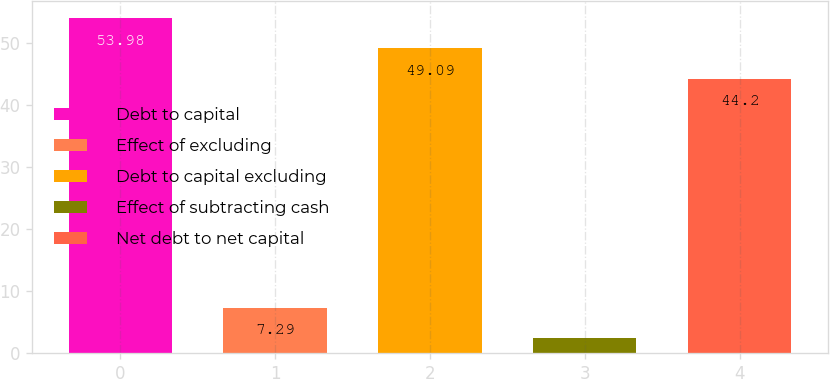Convert chart to OTSL. <chart><loc_0><loc_0><loc_500><loc_500><bar_chart><fcel>Debt to capital<fcel>Effect of excluding<fcel>Debt to capital excluding<fcel>Effect of subtracting cash<fcel>Net debt to net capital<nl><fcel>53.98<fcel>7.29<fcel>49.09<fcel>2.4<fcel>44.2<nl></chart> 